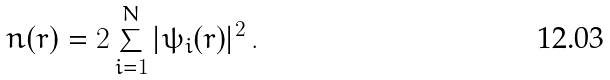Convert formula to latex. <formula><loc_0><loc_0><loc_500><loc_500>n ( { r } ) = 2 \sum _ { i = 1 } ^ { N } | \psi _ { i } ( { r } ) | ^ { 2 } \, .</formula> 